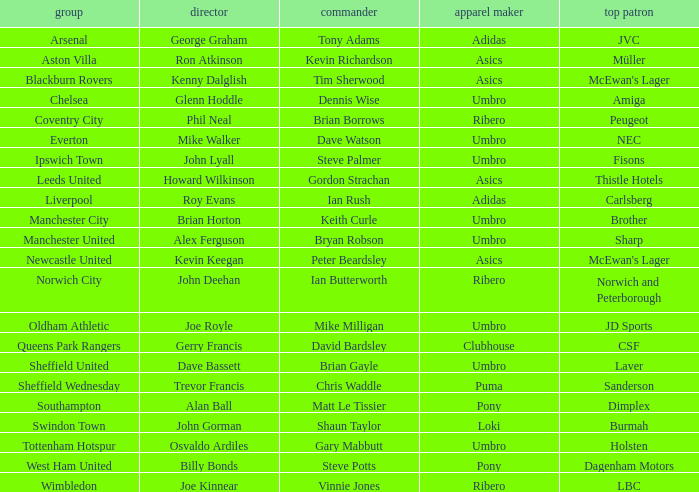Which captain has howard wilkinson as the manager? Gordon Strachan. 